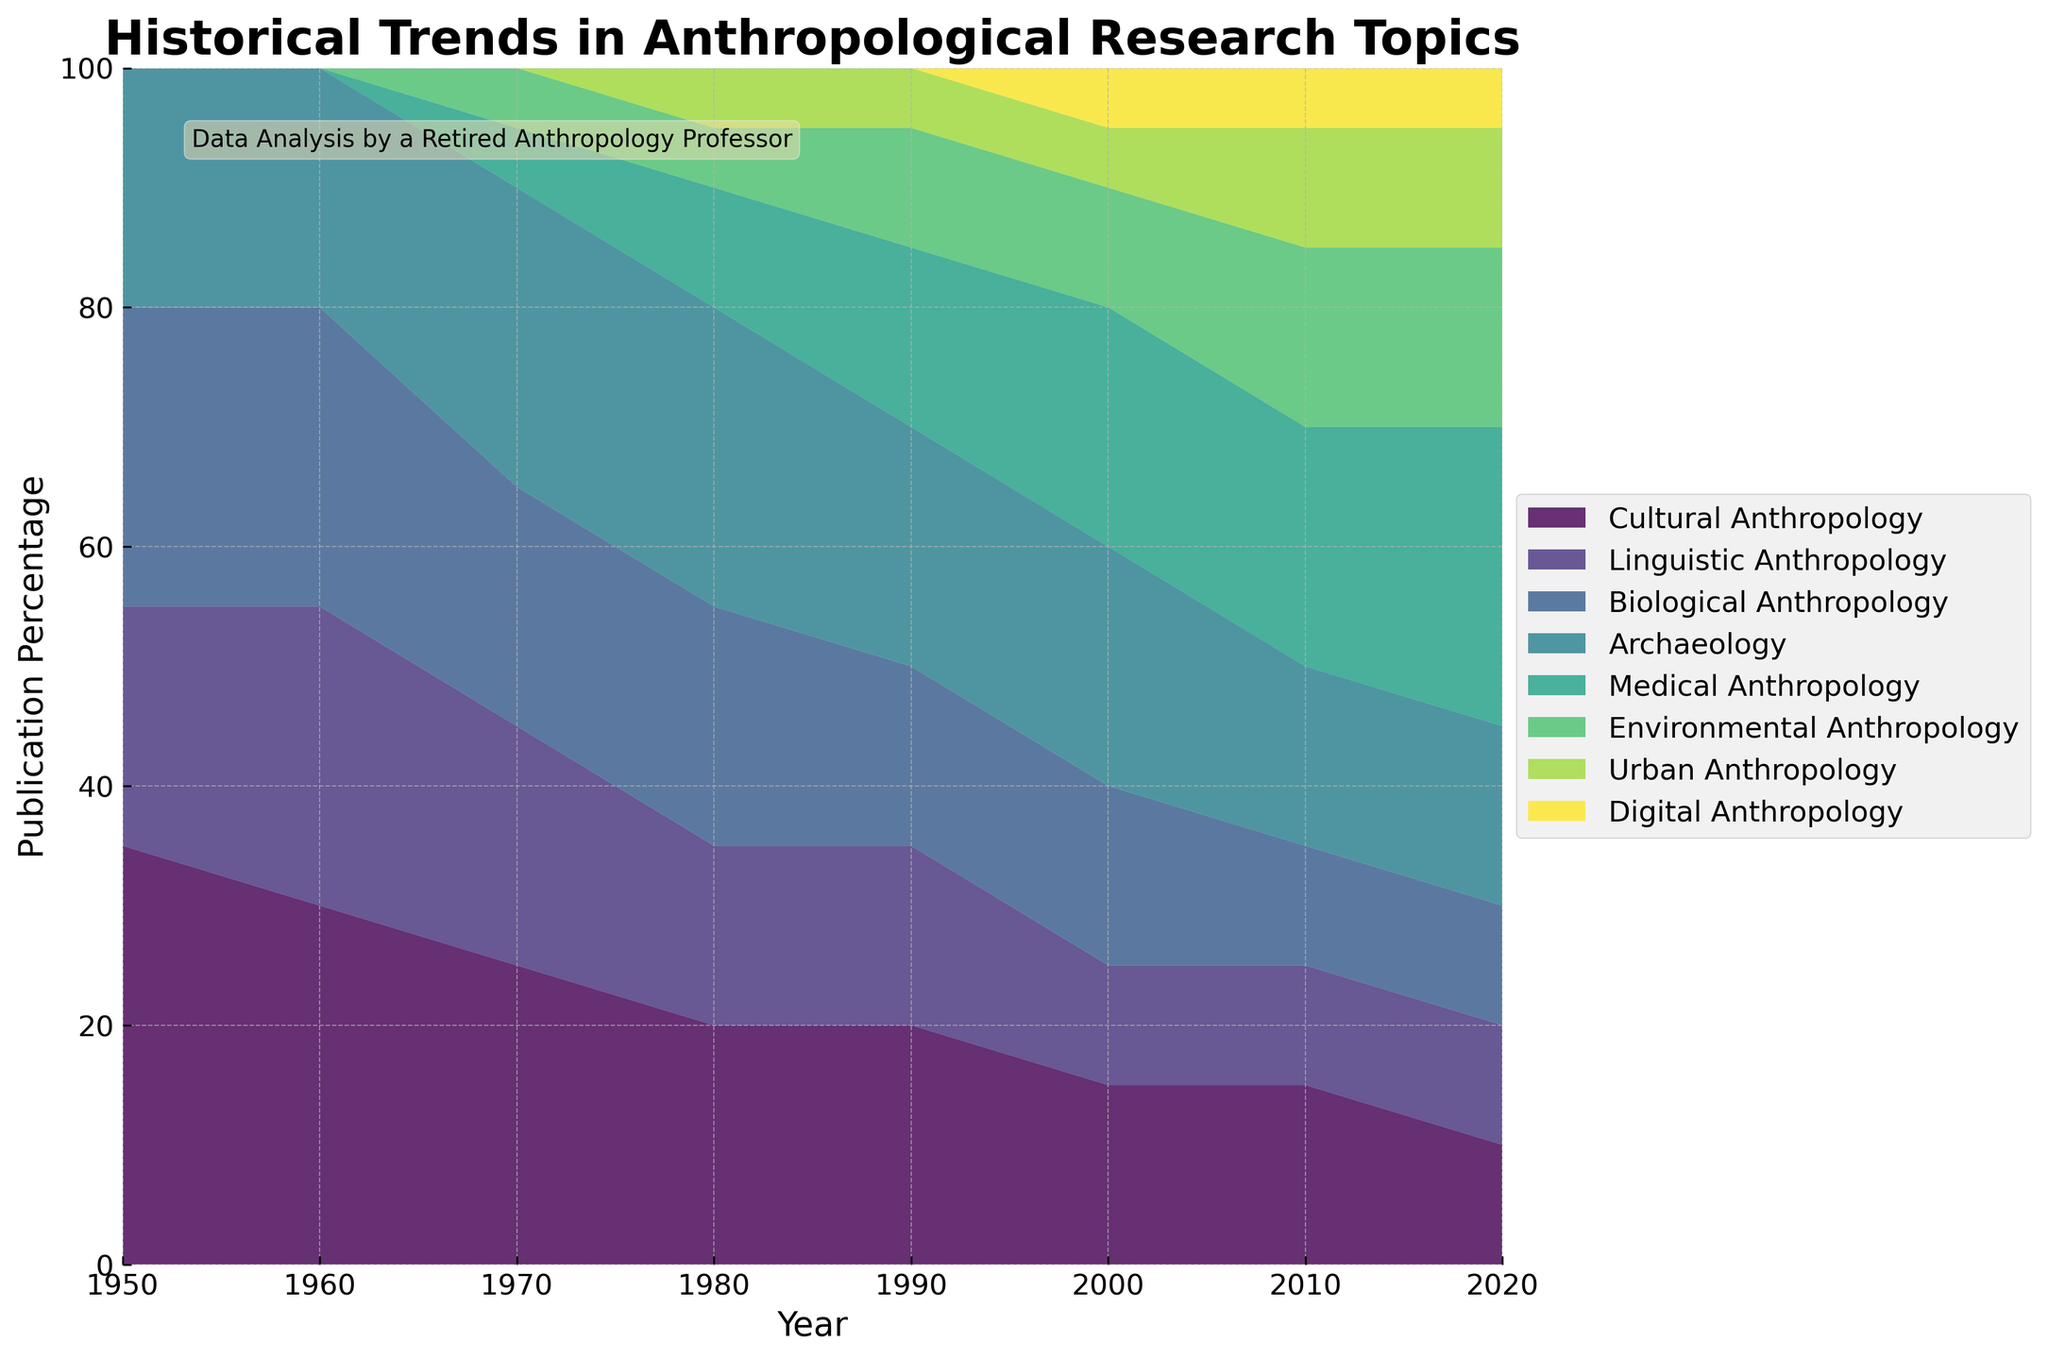What is the title of the figure? The title of a figure is typically located at the top and describes the main subject of the visualization. In this case, it reads "Historical Trends in Anthropological Research Topics."
Answer: Historical Trends in Anthropological Research Topics What were the two dominant research topics in anthropology in 1950? By examining the graph for the year 1950, the two largest areas, represented by the height of the stacked sections, are Cultural Anthropology and Biological Anthropology.
Answer: Cultural Anthropology, Biological Anthropology At what period did Medical Anthropology start to gain prominence? From the visual data, Medical Anthropology appears for the first time in 1970 with an emergent 5%. This indicates that it started gaining prominence around this time.
Answer: 1970 How did the percentage of publications in Cultural Anthropology change from 1950 to 2020? Looking at the graph, Cultural Anthropology starts at 35% in 1950 and declines to 10% in 2020.
Answer: Declined Which subfield showed the most significant increase in publication percentage from 1950 to 2020? By observing the changes, Medical Anthropology goes from 0% in 1950 to 25% in 2020, an increase of 25 percentage points, the highest among all.
Answer: Medical Anthropology What is the general trend of publications in Archaeology from 1950 to 2020? Over time, the visual showcases that Archaeology publications start at 20%, peak at 25% around 1970-1980, and then stabilize at about 15% from 2010 to 2020.
Answer: Fluctuates then stabilizes For how many years was the publication percentage in Linguistic Anthropology at or above 20%? The chart visually indicates that Linguistic Anthropology was above or equal to 20% from 1950 to around 1970.
Answer: 30 years Which subfield maintained a constant publication percentage from 1980 to 2020? The chart shows Environmental Anthropology at a consistent 5% from 1980 to 2020 without fluctuation.
Answer: Environmental Anthropology By how much did the percentage of Medical Anthropology publications vary between 1990 and 2000? Medical Anthropology shows a change from 15% in 1990 to 20% in 2000, reflecting a 5% increase.
Answer: Increased by 5% When did Digital Anthropology first appear in the publication trends? From the visual, Digital Anthropology makes its first appearance at 5% in the year 2000.
Answer: 2000 